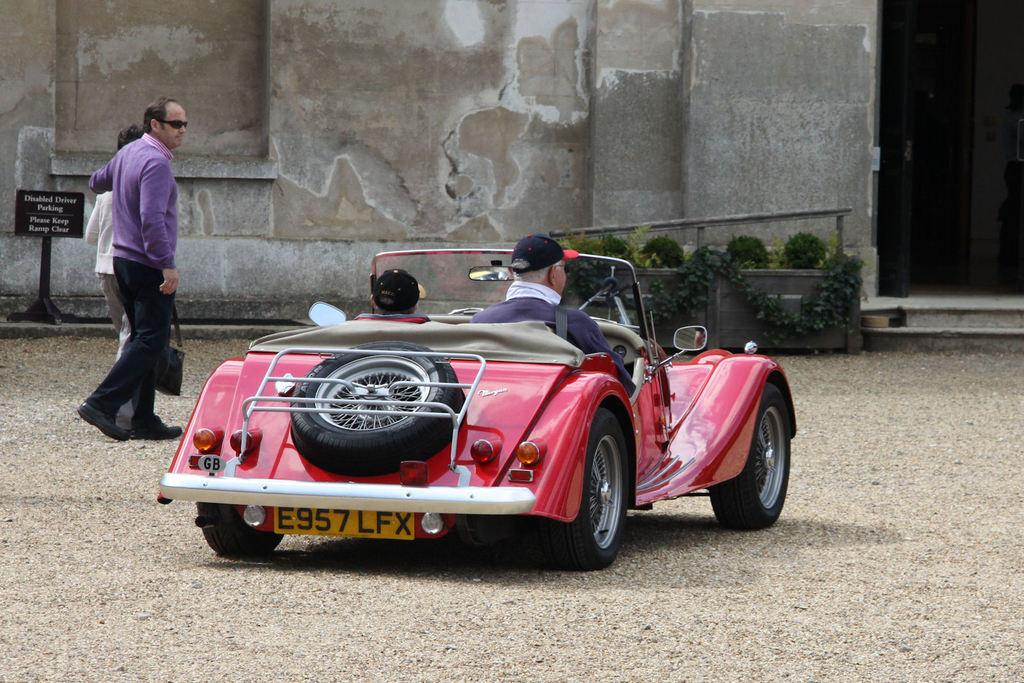How many people are driving the car in the image? There are two people driving the car in the image. What is the car doing in relation to the couple standing nearby? The car is passing by the couple standing nearby. What type of iron is being used by the couple standing nearby? There is no iron present in the image; it features a car passing by a couple standing nearby. What color is the skin of the people driving the car? The provided facts do not mention the color of the people's skin, so it cannot be determined from the image. 